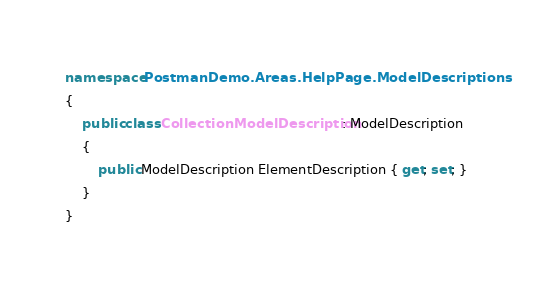Convert code to text. <code><loc_0><loc_0><loc_500><loc_500><_C#_>namespace PostmanDemo.Areas.HelpPage.ModelDescriptions
{
    public class CollectionModelDescription : ModelDescription
    {
        public ModelDescription ElementDescription { get; set; }
    }
}</code> 